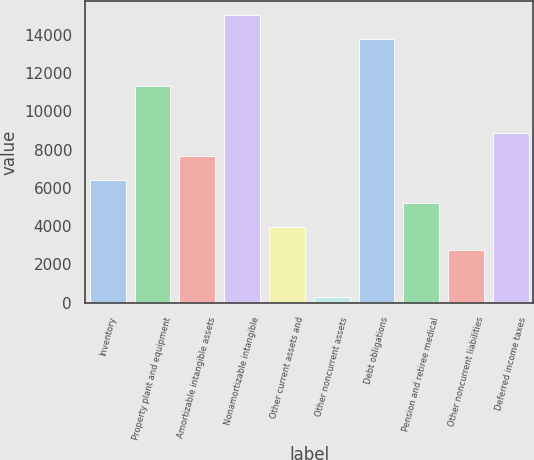Convert chart. <chart><loc_0><loc_0><loc_500><loc_500><bar_chart><fcel>Inventory<fcel>Property plant and equipment<fcel>Amortizable intangible assets<fcel>Nonamortizable intangible<fcel>Other current assets and<fcel>Other noncurrent assets<fcel>Debt obligations<fcel>Pension and retiree medical<fcel>Other noncurrent liabilities<fcel>Deferred income taxes<nl><fcel>6418.5<fcel>11328.5<fcel>7646<fcel>15011<fcel>3963.5<fcel>281<fcel>13783.5<fcel>5191<fcel>2736<fcel>8873.5<nl></chart> 